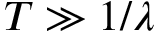Convert formula to latex. <formula><loc_0><loc_0><loc_500><loc_500>T \gg 1 / \lambda</formula> 